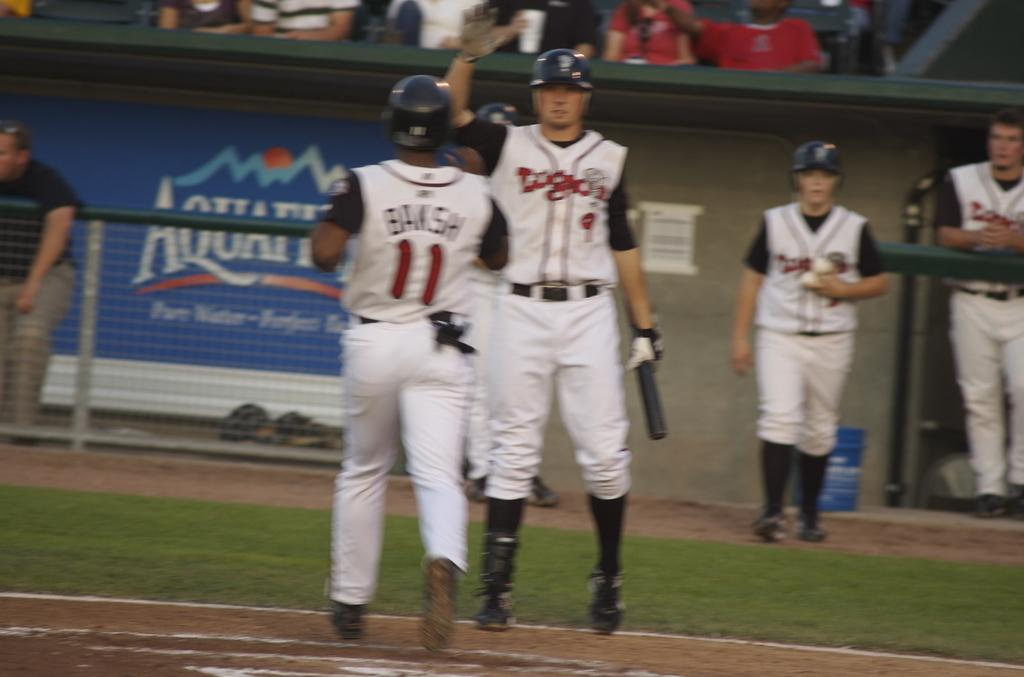Provide a one-sentence caption for the provided image. Baseball player number 9 holds his hand up to high five player 11. 